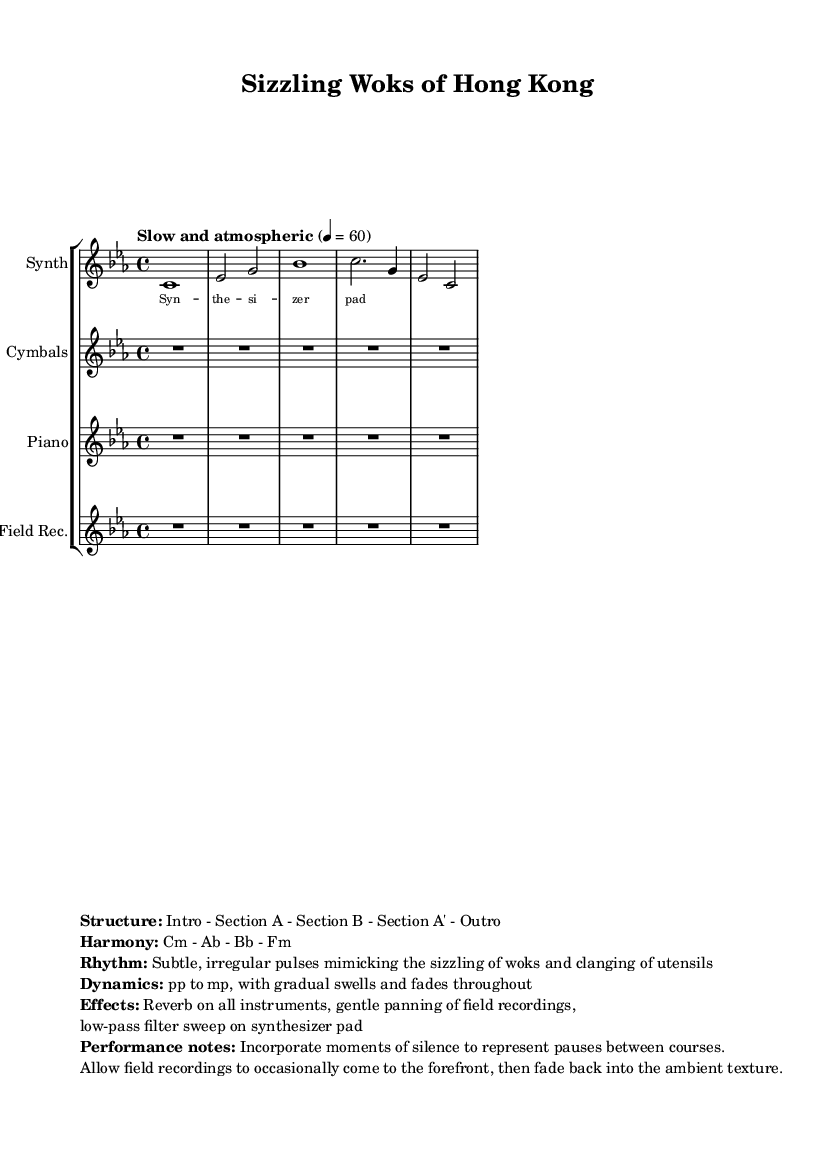What is the time signature of this music? The time signature is indicated in the sheet music as 4/4, which means there are four beats in each measure and a quarter note receives one beat.
Answer: 4/4 What is the tempo of this composition? The tempo is specified as "Slow and atmospheric" with a metronome marking of 60 beats per minute. This indicates a relaxed pace for the music.
Answer: 60 What is the key signature of this piece? The key signature is C minor, which has three flats (B♭, E♭, and A♭) and indicates the overall tonality of the piece.
Answer: C minor What are the main instruments used in this composition? The composition includes a Synth, Bowed Cymbals, Prepared Piano, and Field Recordings, as indicated by the instrument names listed in the score.
Answer: Synth, Bowed Cymbals, Prepared Piano, Field Recordings How many sections does this piece have? The structure of the composition is outlined as having an Intro, Section A, Section B, Section A', and an Outro, which totals five distinct sections.
Answer: 5 What types of dynamics are used in this piece? The dynamics are described as ranging from pianissimo (pp) to mezzo-piano (mp), with gradual swells and fades, showcasing a gentle and fluid dynamic range throughout the composition.
Answer: pp to mp What performance notes are provided in this composition? The performance notes include incorporating moments of silence to represent pauses between courses and allowing field recordings to occasionally come to the forefront before fading back.
Answer: Incorporate moments of silence 